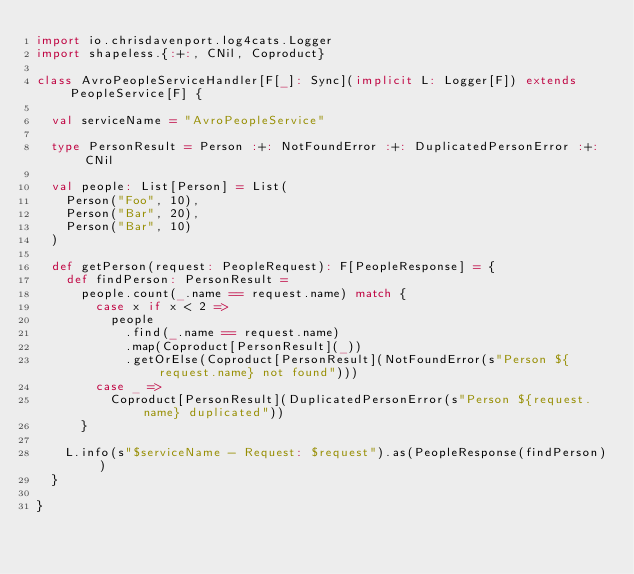Convert code to text. <code><loc_0><loc_0><loc_500><loc_500><_Scala_>import io.chrisdavenport.log4cats.Logger
import shapeless.{:+:, CNil, Coproduct}

class AvroPeopleServiceHandler[F[_]: Sync](implicit L: Logger[F]) extends PeopleService[F] {

  val serviceName = "AvroPeopleService"

  type PersonResult = Person :+: NotFoundError :+: DuplicatedPersonError :+: CNil

  val people: List[Person] = List(
    Person("Foo", 10),
    Person("Bar", 20),
    Person("Bar", 10)
  )

  def getPerson(request: PeopleRequest): F[PeopleResponse] = {
    def findPerson: PersonResult =
      people.count(_.name == request.name) match {
        case x if x < 2 =>
          people
            .find(_.name == request.name)
            .map(Coproduct[PersonResult](_))
            .getOrElse(Coproduct[PersonResult](NotFoundError(s"Person ${request.name} not found")))
        case _ =>
          Coproduct[PersonResult](DuplicatedPersonError(s"Person ${request.name} duplicated"))
      }

    L.info(s"$serviceName - Request: $request").as(PeopleResponse(findPerson))
  }

}
</code> 